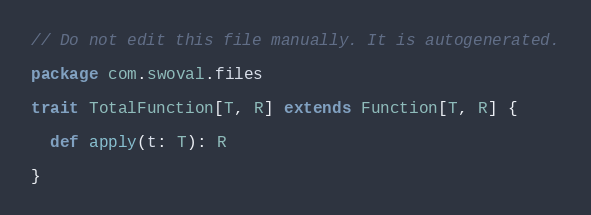<code> <loc_0><loc_0><loc_500><loc_500><_Scala_>// Do not edit this file manually. It is autogenerated.

package com.swoval.files

trait TotalFunction[T, R] extends Function[T, R] {

  def apply(t: T): R

}
</code> 